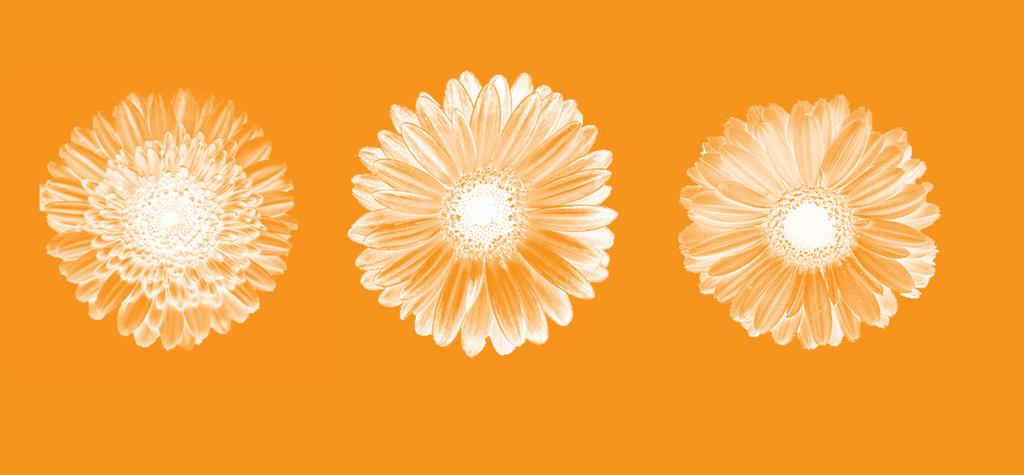What is depicted in the image? There is a drawing of flowers in the image. Can you describe the flowers in the drawing? The provided facts do not include a description of the flowers, so we cannot provide specific details about them. What medium might have been used to create the drawing? The facts do not specify the medium used to create the drawing, so we cannot determine if it was created with pencil, paint, or any other material. What decision did the flowers make in the image? There are no decisions made by the flowers in the image, as they are a drawing and do not have the ability to make decisions. 